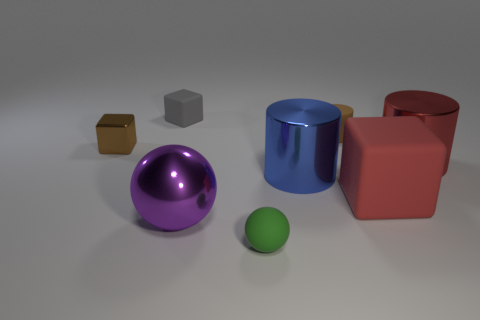Subtract all rubber blocks. How many blocks are left? 1 Add 1 tiny brown metal things. How many objects exist? 9 Subtract all balls. How many objects are left? 6 Subtract all tiny spheres. Subtract all purple shiny things. How many objects are left? 6 Add 8 red blocks. How many red blocks are left? 9 Add 4 tiny gray matte blocks. How many tiny gray matte blocks exist? 5 Subtract 1 red cylinders. How many objects are left? 7 